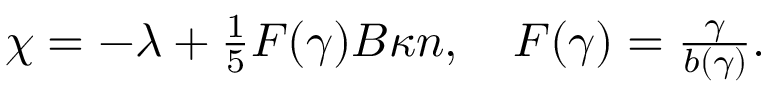Convert formula to latex. <formula><loc_0><loc_0><loc_500><loc_500>\begin{array} { r } { \chi = - \lambda + \frac { 1 } { 5 } F ( \gamma ) B \kappa n , \quad F ( \gamma ) = \frac { \gamma } { b ( \gamma ) } . } \end{array}</formula> 